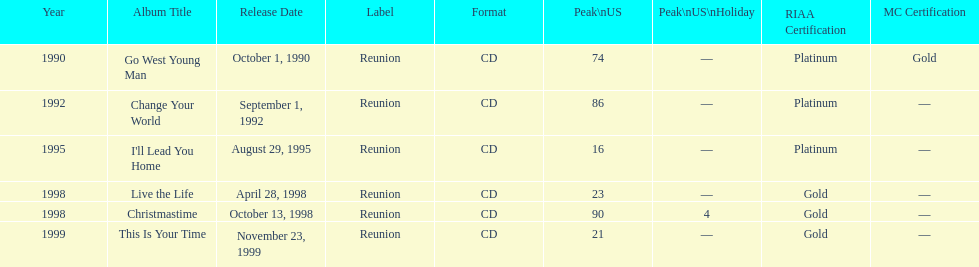Which michael w smith album had the highest ranking on the us chart? I'll Lead You Home. 